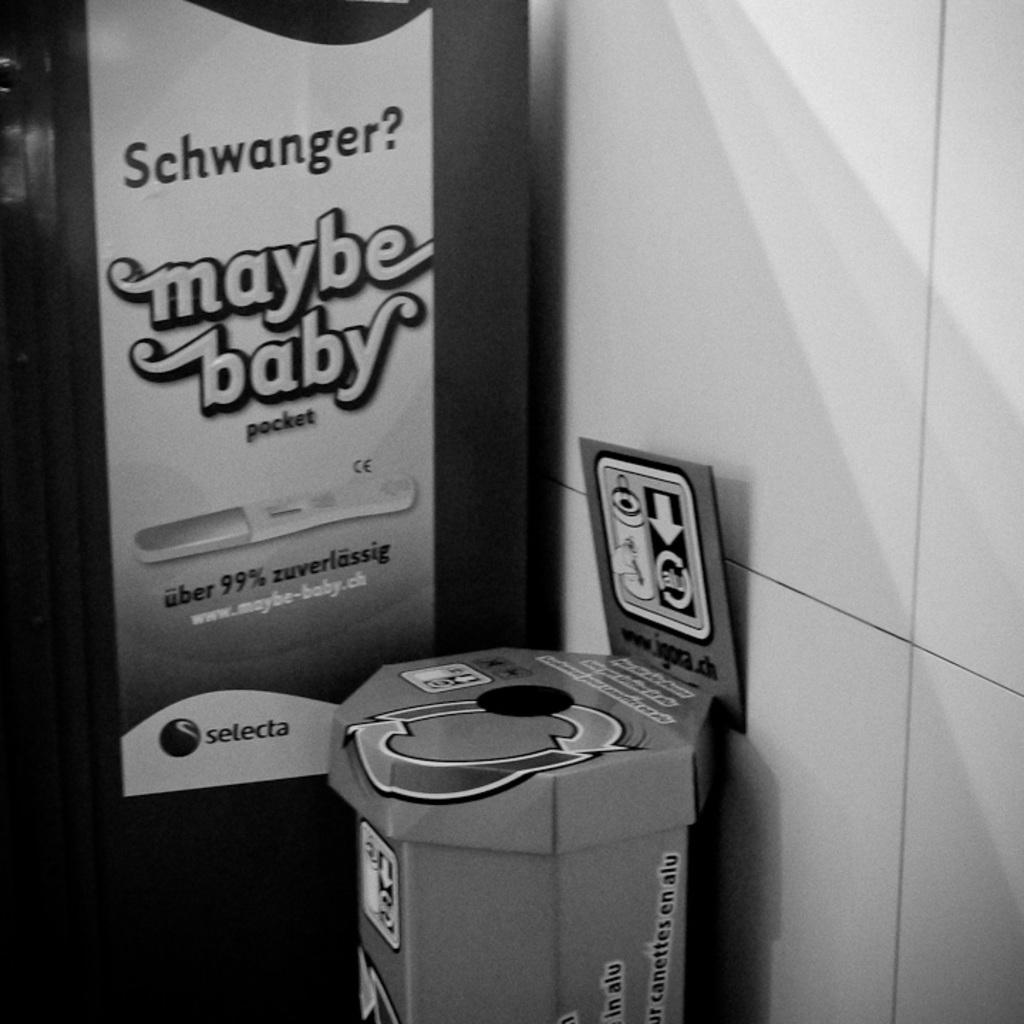Provide a one-sentence caption for the provided image. An recycling can sits beside an ad for a pregnancy test. 